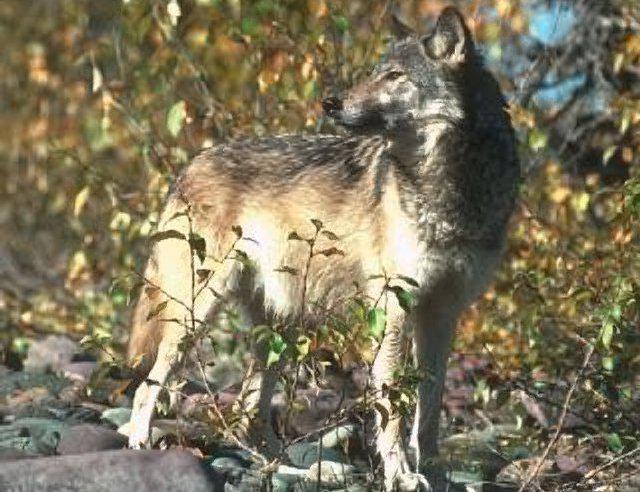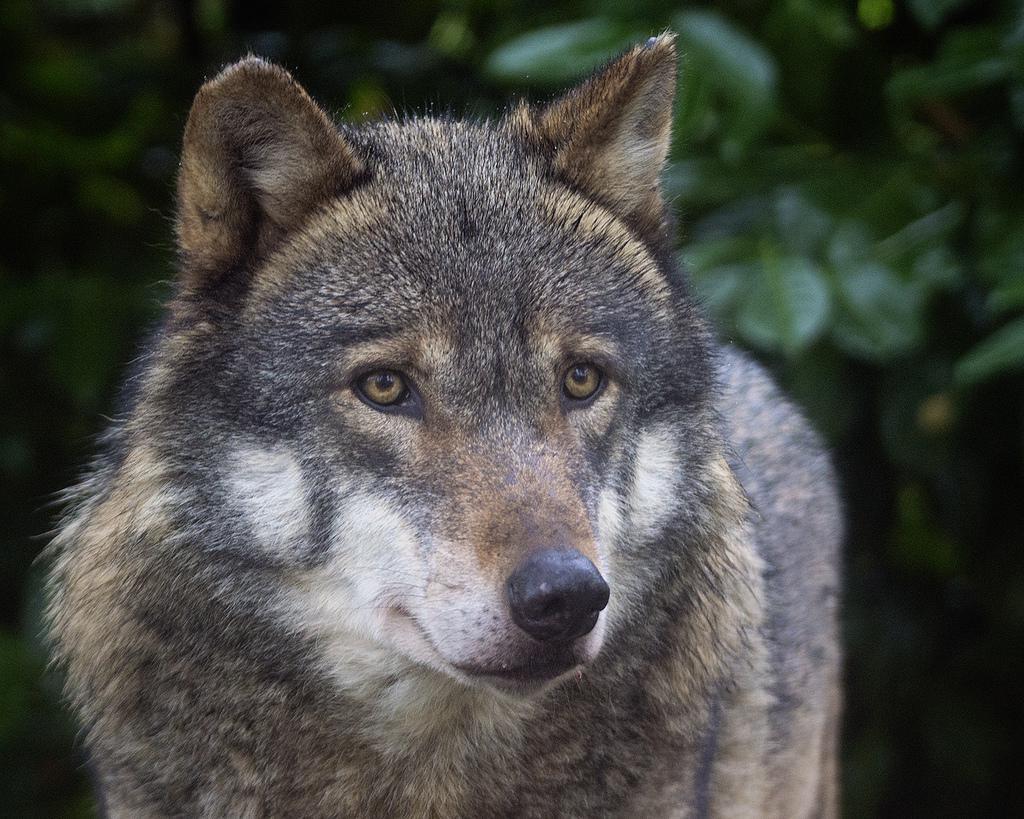The first image is the image on the left, the second image is the image on the right. Assess this claim about the two images: "Each image contains exactly one wolf, and one image shows a wolf with an open, non-snarling mouth.". Correct or not? Answer yes or no. No. 